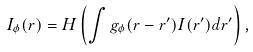Convert formula to latex. <formula><loc_0><loc_0><loc_500><loc_500>I _ { \phi } ( { r } ) = H \left ( \int g _ { \phi } ( { r } - { r } ^ { \prime } ) I ( { r } ^ { \prime } ) d { r } ^ { \prime } \right ) ,</formula> 